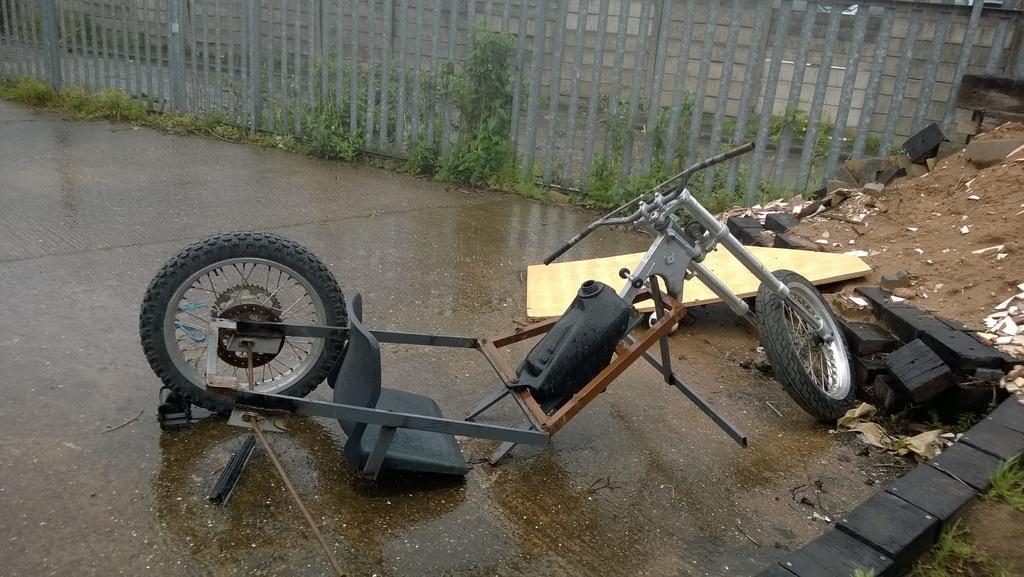Can you describe this image briefly? In this image I can see two wheels, a seat, handle. At the back I can see railing and small plants in green color 